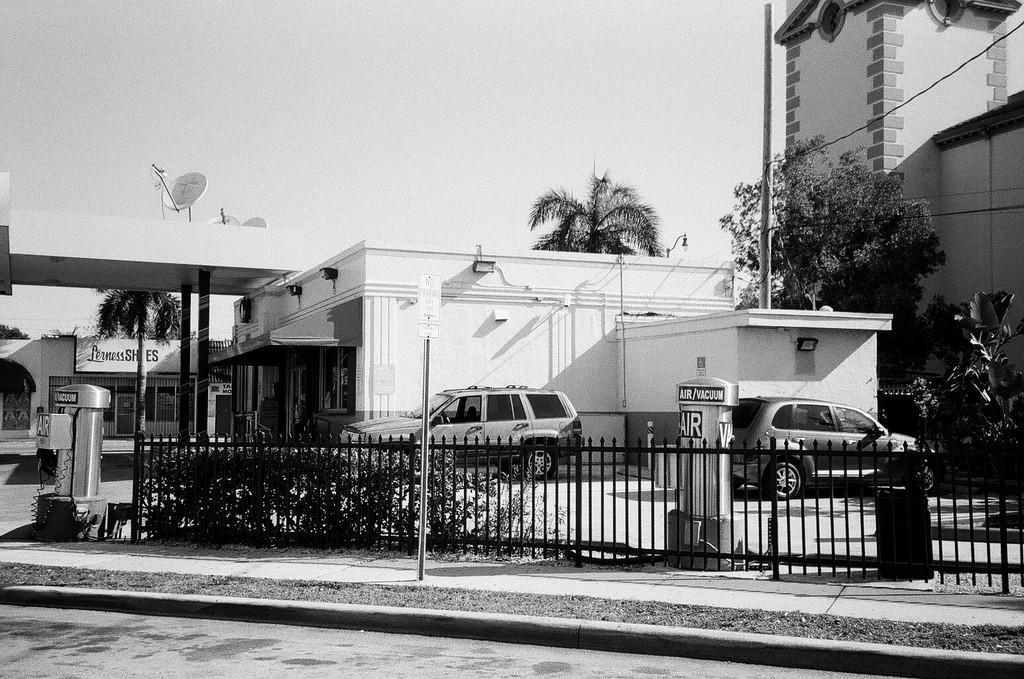Can you describe this image briefly? It looks like a black and white picture. We can see a pole, iron grilles, plants and those are looking like air machines. Behind the air machines, there are vehicles on the road. Behind the vehicles there are trees, buildings, cables and the sky. On the building there are antennas. 